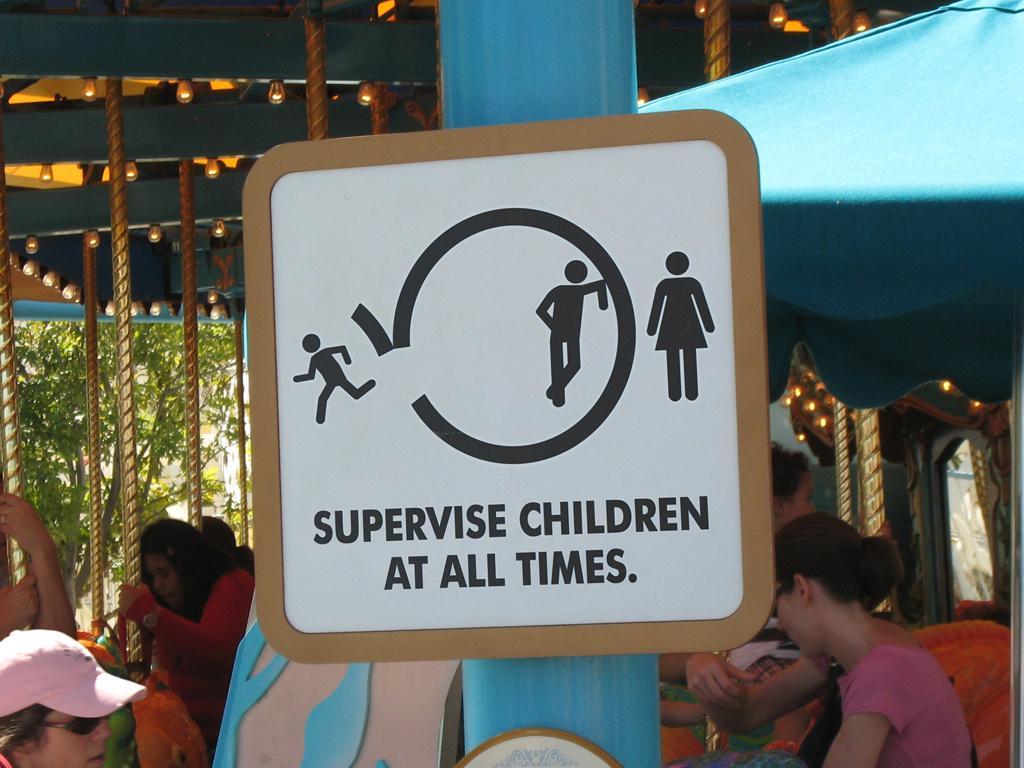Please provide a concise description of this image. In this picture in the front there is a pole. On the pole there is a board with some text written on it. In the background there are persons, there are lights and there is a tent which is blue in colour and there are trees. 